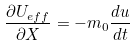<formula> <loc_0><loc_0><loc_500><loc_500>\frac { \partial U _ { e f f } } { \partial X } = - m _ { 0 } \frac { d u } { d t }</formula> 